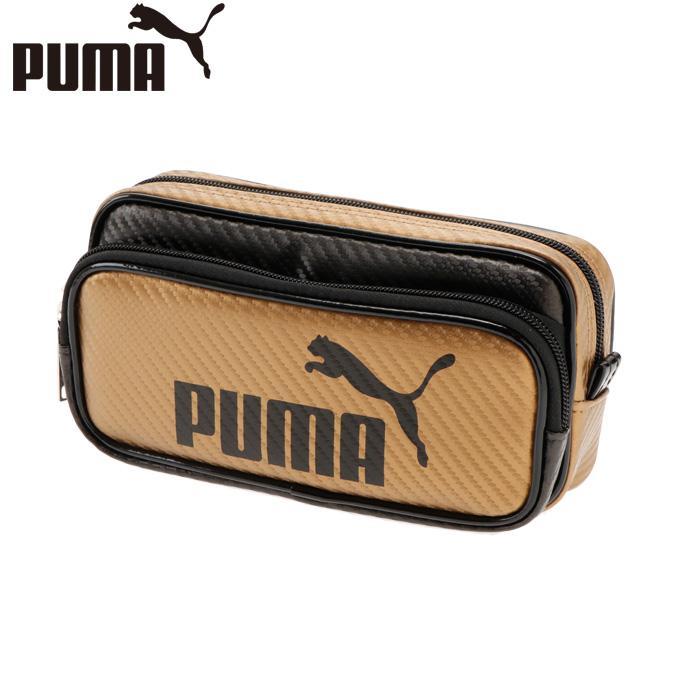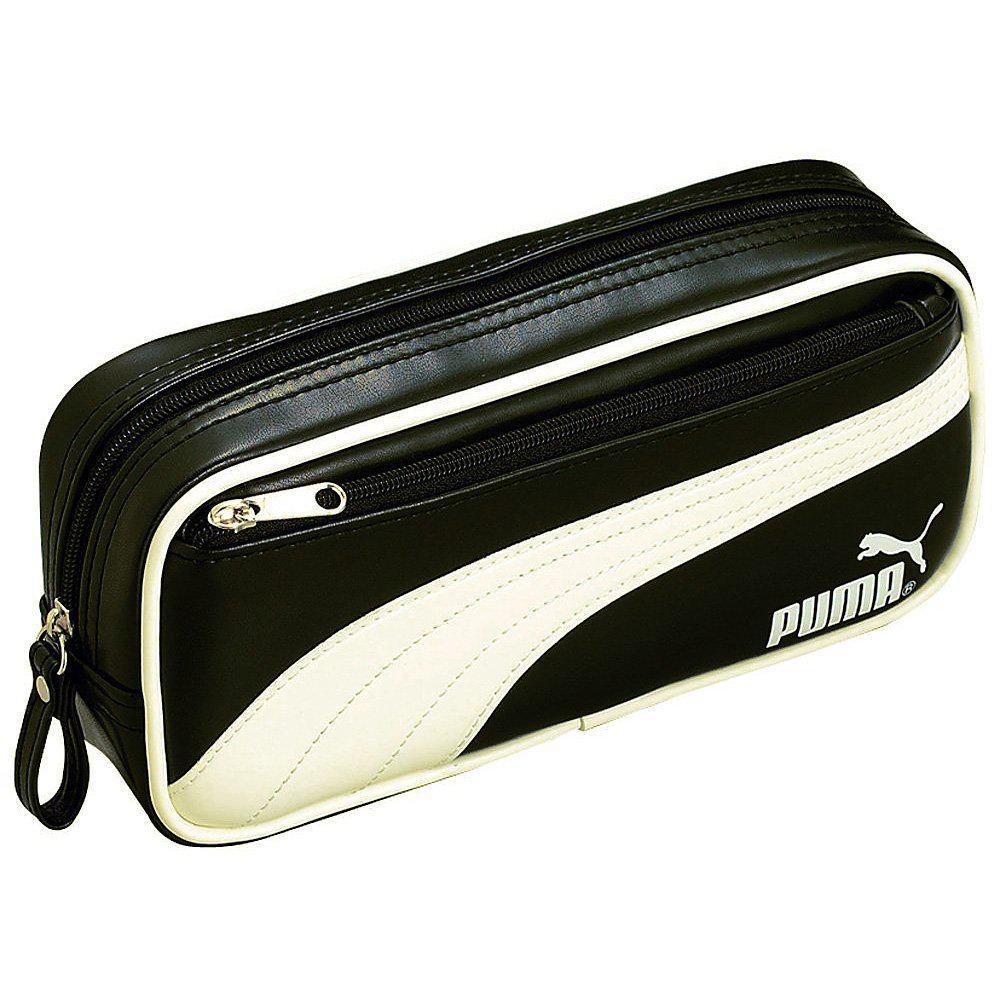The first image is the image on the left, the second image is the image on the right. Analyze the images presented: Is the assertion "Each image contains one pencil case with a wildcat silhouette on it, and the right image features a case with a curving line that separates its colors." valid? Answer yes or no. Yes. The first image is the image on the left, the second image is the image on the right. Considering the images on both sides, is "Exactly one bag has the company name and the company logo on it." valid? Answer yes or no. No. 